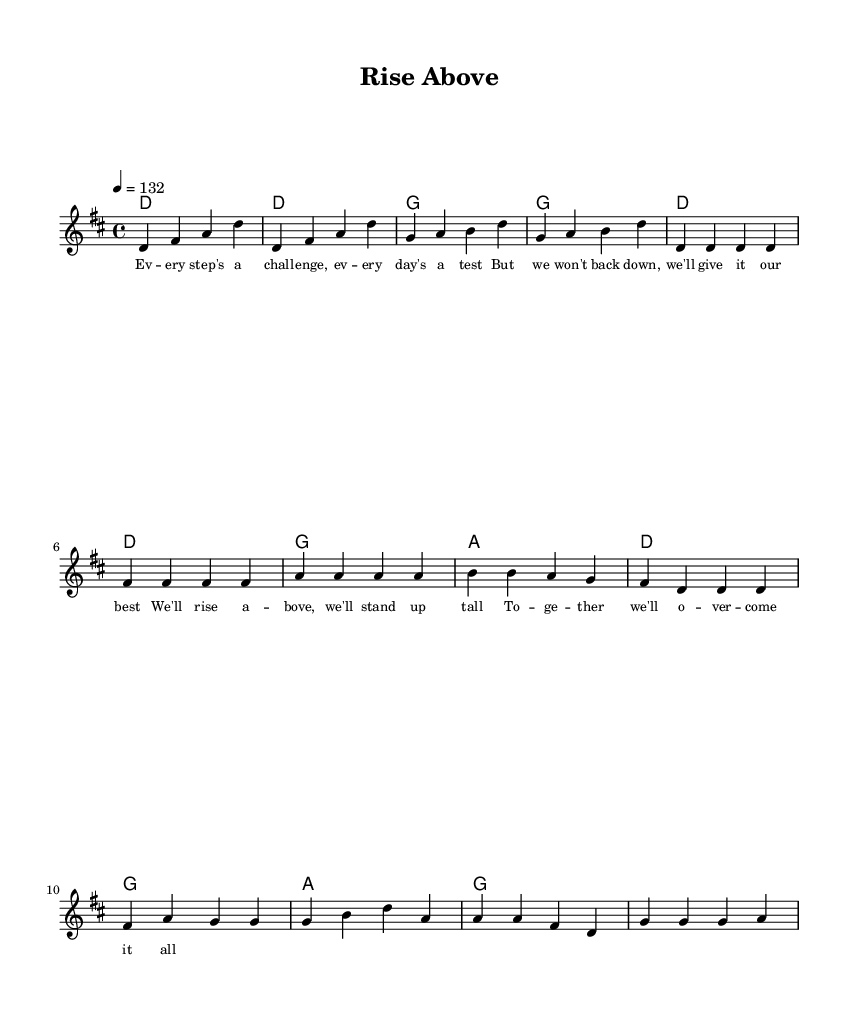What is the key signature of this music? The key signature is D major, which has two sharps (F# and C#). We determine this by looking at the key signature indication at the beginning of the score, which specifies the key.
Answer: D major What is the time signature of this music? The time signature is 4/4, which indicates four beats per measure, and the quarter note gets one beat. We can find this by examining the time signature displayed in the beginning part of the score.
Answer: 4/4 What is the tempo marking of this piece? The tempo marking is 132, indicating the tempo in beats per minute. The tempo is found near the start of the score, specifying how fast the piece should be played.
Answer: 132 How many measures are in the verse section? There are four measures in the verse section. By counting the number of measures (each separated by a vertical line) in the “Verse” part of the melody, we find this information.
Answer: Four What is the first lyric of the chorus? The first lyric of the chorus is "We'll". We look at the lyrics aligned with the melody in the score and identify the first word of the chorus section.
Answer: We'll How many different chords are used in the chorus? There are three different chords used in the chorus: D, G, and A. By examining the chord symbols shown above the melody in the chorus section, we can distinguish the distinct chords played.
Answer: Three What type of song structure does this piece follow? The song structure follows a verse-chorus format. This can be determined by analyzing the layout of the sections indicated in the score: a verse is followed by a chorus, which is a common structure in many popular songs.
Answer: Verse-chorus 